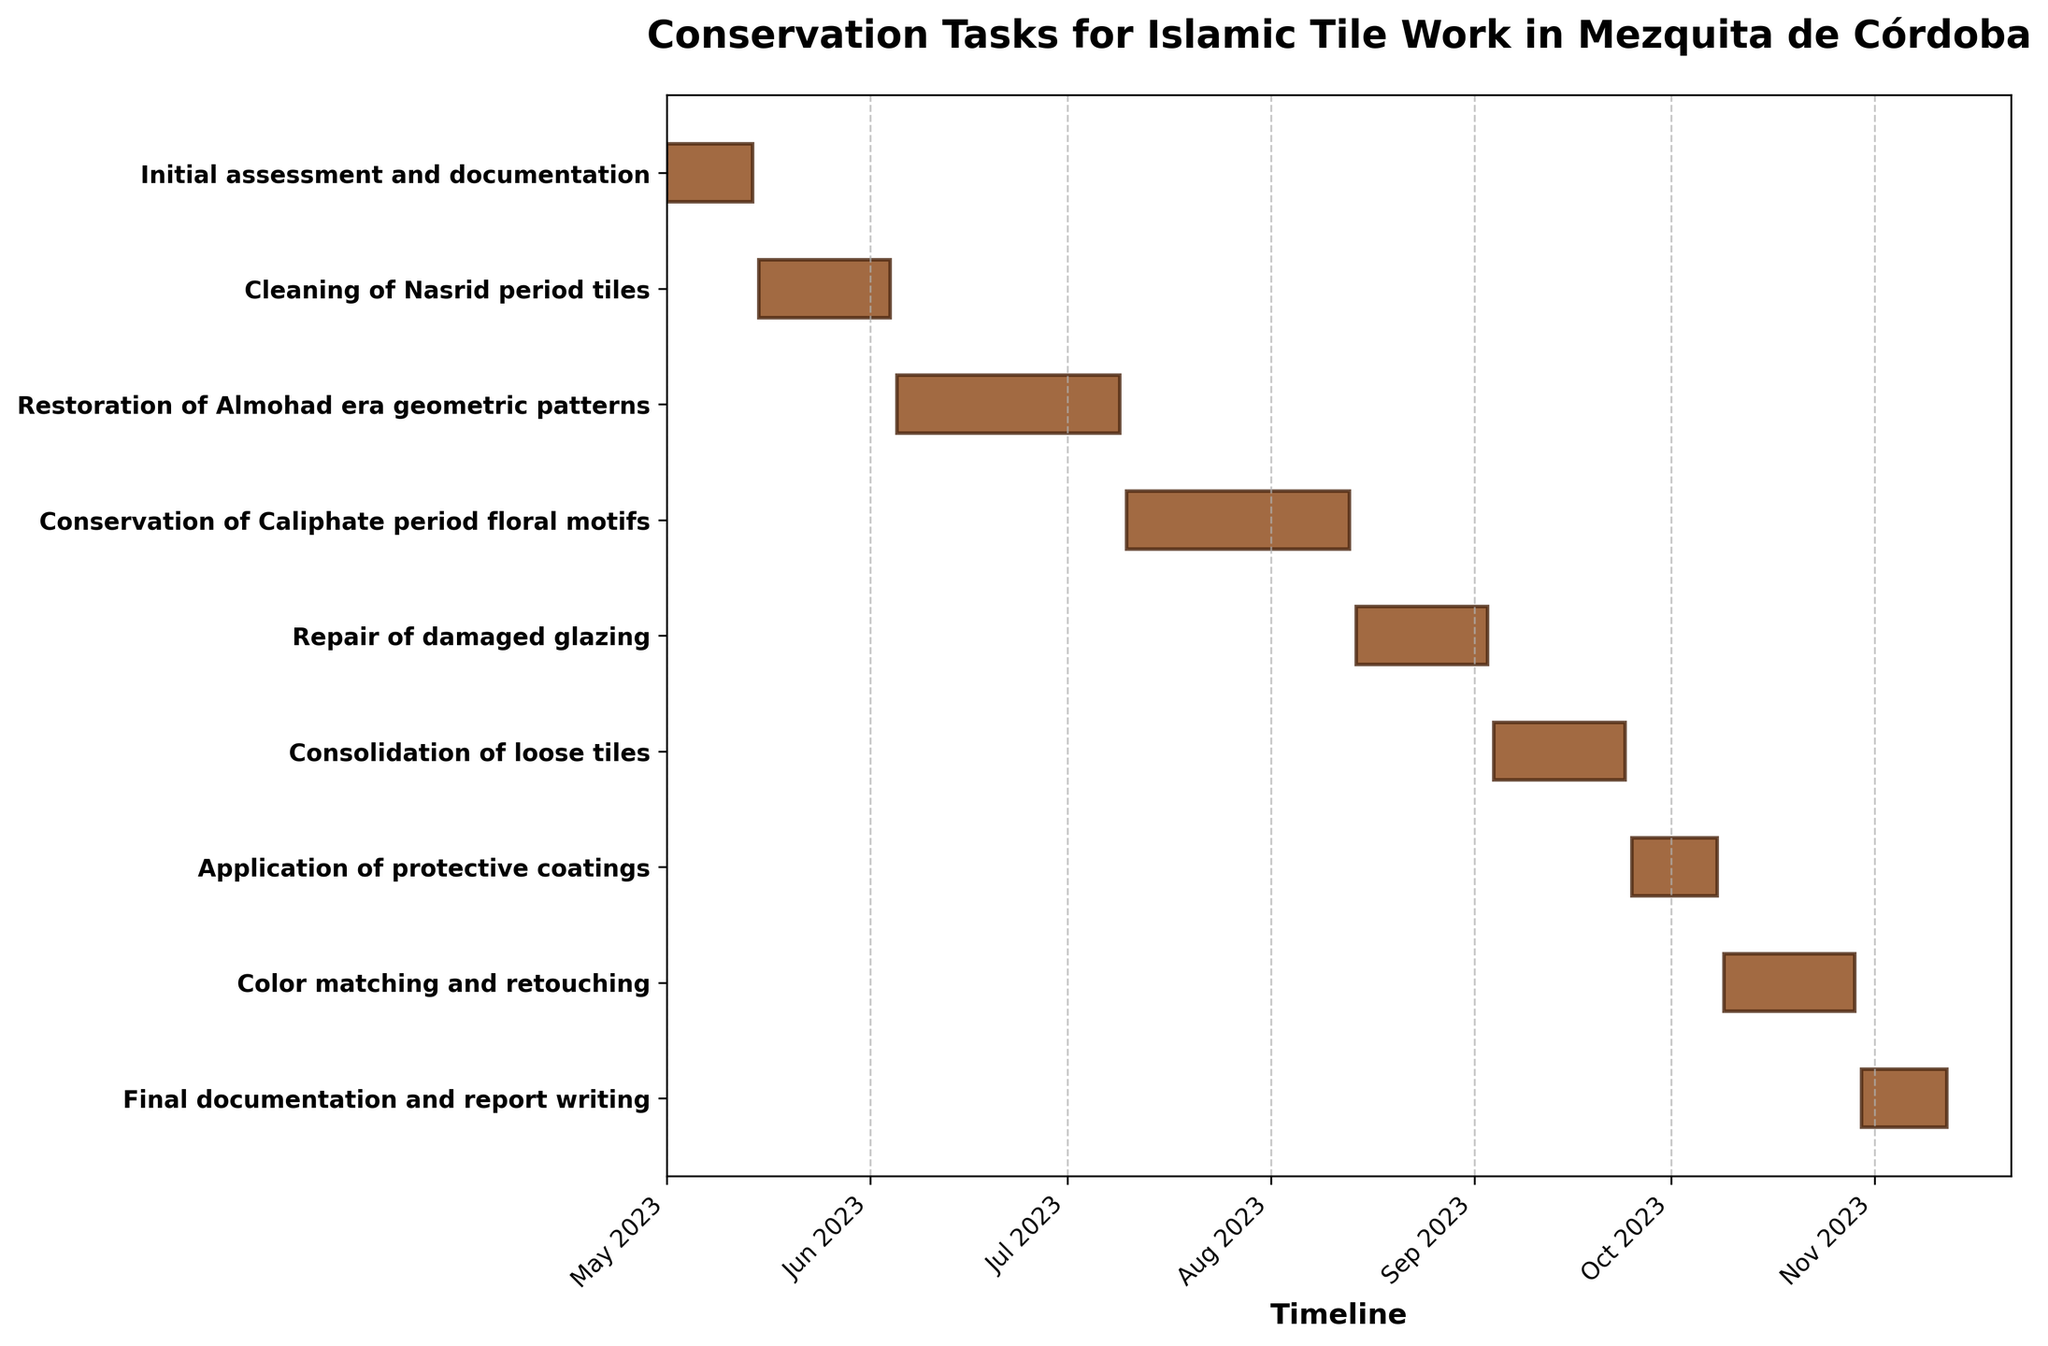What is the title of the chart? Look at the top center of the plot where the title is typically placed. The title should clearly state what the chart is about.
Answer: Conservation Tasks for Islamic Tile Work in Mezquita de Córdoba How long does the "Cleaning of Nasrid period tiles" task take? Refer to the bar labeled "Cleaning of Nasrid period tiles" on the y-axis and check its length, which represents the task duration.
Answer: 21 days What's the total duration for the tasks related to geometric patterns and floral motifs? Find the bars for "Restoration of Almohad era geometric patterns" (35 days) and "Conservation of Caliphate period floral motifs" (35 days). Add their durations together.
Answer: 70 days Which task starts earliest, and which one starts the latest? Identify the bar farthest to the left on the timeline for the earliest start, and the one farthest to the right for the latest start.
Answer: Initial assessment and documentation, Final documentation and report writing During which month does the "Repair of damaged glazing" task take place? Find the bar for "Repair of damaged glazing" and note its position on the x-axis to determine the month.
Answer: August 2023 Which task has the same duration as "Final documentation and report writing"? First, identify the duration of "Final documentation and report writing" (14 days), then find another bar of the same length.
Answer: Initial assessment and documentation, Application of protective coatings In which months does the "Consolidation of loose tiles" task occur? Check the timeline position of "Consolidation of loose tiles" to determine the crossing months.
Answer: September 2023 How many tasks are longer than 20 days? Count the bars with a duration visually longer than 20 days. These bars will appear longer and exceed three weeks on the timeline.
Answer: 4 tasks When does the "Application of protective coatings" task end? Look at the end date of the bar labeled "Application of protective coatings" on the y-axis.
Answer: October 08, 2023 Which tasks have overlapping time periods and what are they? Look for bars that share parts of their lengths on the timeline to determine overlap. Check specific start and end dates to confirm.
Answer: Cleaning of Nasrid period tiles and Restoration of Almohad era geometric patterns; Conservation of Caliphate period floral motifs and Repair of damaged glazing 